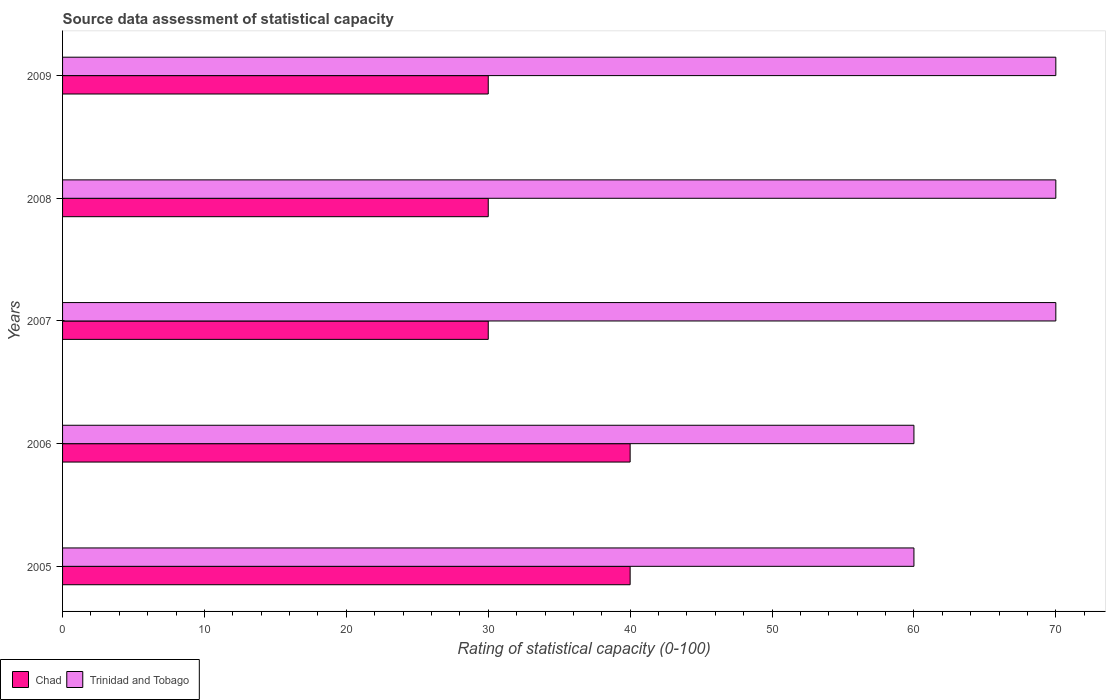How many different coloured bars are there?
Provide a succinct answer. 2. How many groups of bars are there?
Give a very brief answer. 5. Are the number of bars per tick equal to the number of legend labels?
Provide a short and direct response. Yes. Are the number of bars on each tick of the Y-axis equal?
Give a very brief answer. Yes. What is the label of the 3rd group of bars from the top?
Offer a very short reply. 2007. In how many cases, is the number of bars for a given year not equal to the number of legend labels?
Provide a short and direct response. 0. What is the rating of statistical capacity in Chad in 2009?
Your answer should be very brief. 30. Across all years, what is the maximum rating of statistical capacity in Trinidad and Tobago?
Provide a short and direct response. 70. Across all years, what is the minimum rating of statistical capacity in Trinidad and Tobago?
Provide a succinct answer. 60. In which year was the rating of statistical capacity in Chad maximum?
Offer a terse response. 2005. In which year was the rating of statistical capacity in Chad minimum?
Provide a short and direct response. 2007. What is the total rating of statistical capacity in Chad in the graph?
Your answer should be very brief. 170. What is the difference between the rating of statistical capacity in Chad in 2006 and that in 2009?
Give a very brief answer. 10. What is the difference between the rating of statistical capacity in Chad in 2006 and the rating of statistical capacity in Trinidad and Tobago in 2005?
Your answer should be compact. -20. What is the average rating of statistical capacity in Chad per year?
Offer a terse response. 34. In the year 2009, what is the difference between the rating of statistical capacity in Trinidad and Tobago and rating of statistical capacity in Chad?
Offer a very short reply. 40. What is the ratio of the rating of statistical capacity in Trinidad and Tobago in 2008 to that in 2009?
Give a very brief answer. 1. What is the difference between the highest and the lowest rating of statistical capacity in Trinidad and Tobago?
Make the answer very short. 10. In how many years, is the rating of statistical capacity in Trinidad and Tobago greater than the average rating of statistical capacity in Trinidad and Tobago taken over all years?
Make the answer very short. 3. What does the 2nd bar from the top in 2006 represents?
Offer a terse response. Chad. What does the 2nd bar from the bottom in 2005 represents?
Offer a very short reply. Trinidad and Tobago. How many bars are there?
Keep it short and to the point. 10. How many years are there in the graph?
Your response must be concise. 5. What is the difference between two consecutive major ticks on the X-axis?
Offer a very short reply. 10. Does the graph contain any zero values?
Make the answer very short. No. Where does the legend appear in the graph?
Give a very brief answer. Bottom left. How are the legend labels stacked?
Provide a short and direct response. Horizontal. What is the title of the graph?
Provide a succinct answer. Source data assessment of statistical capacity. Does "Greenland" appear as one of the legend labels in the graph?
Your answer should be compact. No. What is the label or title of the X-axis?
Your answer should be very brief. Rating of statistical capacity (0-100). What is the label or title of the Y-axis?
Your answer should be very brief. Years. What is the Rating of statistical capacity (0-100) in Trinidad and Tobago in 2005?
Ensure brevity in your answer.  60. What is the Rating of statistical capacity (0-100) in Trinidad and Tobago in 2006?
Give a very brief answer. 60. What is the Rating of statistical capacity (0-100) in Chad in 2007?
Give a very brief answer. 30. What is the Rating of statistical capacity (0-100) in Trinidad and Tobago in 2009?
Provide a short and direct response. 70. Across all years, what is the maximum Rating of statistical capacity (0-100) in Chad?
Offer a terse response. 40. Across all years, what is the maximum Rating of statistical capacity (0-100) of Trinidad and Tobago?
Offer a very short reply. 70. Across all years, what is the minimum Rating of statistical capacity (0-100) in Chad?
Offer a very short reply. 30. What is the total Rating of statistical capacity (0-100) of Chad in the graph?
Provide a short and direct response. 170. What is the total Rating of statistical capacity (0-100) in Trinidad and Tobago in the graph?
Your response must be concise. 330. What is the difference between the Rating of statistical capacity (0-100) in Trinidad and Tobago in 2005 and that in 2006?
Your answer should be very brief. 0. What is the difference between the Rating of statistical capacity (0-100) of Chad in 2005 and that in 2008?
Give a very brief answer. 10. What is the difference between the Rating of statistical capacity (0-100) of Trinidad and Tobago in 2005 and that in 2008?
Your answer should be compact. -10. What is the difference between the Rating of statistical capacity (0-100) of Chad in 2006 and that in 2007?
Give a very brief answer. 10. What is the difference between the Rating of statistical capacity (0-100) in Trinidad and Tobago in 2006 and that in 2007?
Give a very brief answer. -10. What is the difference between the Rating of statistical capacity (0-100) of Chad in 2006 and that in 2009?
Your answer should be compact. 10. What is the difference between the Rating of statistical capacity (0-100) in Trinidad and Tobago in 2006 and that in 2009?
Your answer should be very brief. -10. What is the difference between the Rating of statistical capacity (0-100) in Chad in 2007 and that in 2008?
Offer a very short reply. 0. What is the difference between the Rating of statistical capacity (0-100) of Trinidad and Tobago in 2007 and that in 2008?
Provide a short and direct response. 0. What is the difference between the Rating of statistical capacity (0-100) in Chad in 2008 and that in 2009?
Offer a terse response. 0. What is the difference between the Rating of statistical capacity (0-100) of Chad in 2005 and the Rating of statistical capacity (0-100) of Trinidad and Tobago in 2007?
Your response must be concise. -30. What is the difference between the Rating of statistical capacity (0-100) in Chad in 2006 and the Rating of statistical capacity (0-100) in Trinidad and Tobago in 2007?
Make the answer very short. -30. What is the difference between the Rating of statistical capacity (0-100) of Chad in 2006 and the Rating of statistical capacity (0-100) of Trinidad and Tobago in 2008?
Your answer should be very brief. -30. What is the difference between the Rating of statistical capacity (0-100) of Chad in 2006 and the Rating of statistical capacity (0-100) of Trinidad and Tobago in 2009?
Keep it short and to the point. -30. What is the average Rating of statistical capacity (0-100) of Chad per year?
Ensure brevity in your answer.  34. What is the average Rating of statistical capacity (0-100) of Trinidad and Tobago per year?
Make the answer very short. 66. In the year 2005, what is the difference between the Rating of statistical capacity (0-100) of Chad and Rating of statistical capacity (0-100) of Trinidad and Tobago?
Your response must be concise. -20. In the year 2009, what is the difference between the Rating of statistical capacity (0-100) in Chad and Rating of statistical capacity (0-100) in Trinidad and Tobago?
Your answer should be compact. -40. What is the ratio of the Rating of statistical capacity (0-100) in Chad in 2005 to that in 2006?
Ensure brevity in your answer.  1. What is the ratio of the Rating of statistical capacity (0-100) of Trinidad and Tobago in 2005 to that in 2006?
Provide a short and direct response. 1. What is the ratio of the Rating of statistical capacity (0-100) in Chad in 2005 to that in 2007?
Provide a succinct answer. 1.33. What is the ratio of the Rating of statistical capacity (0-100) in Chad in 2005 to that in 2008?
Your answer should be very brief. 1.33. What is the ratio of the Rating of statistical capacity (0-100) in Chad in 2005 to that in 2009?
Give a very brief answer. 1.33. What is the ratio of the Rating of statistical capacity (0-100) in Trinidad and Tobago in 2006 to that in 2007?
Provide a succinct answer. 0.86. What is the ratio of the Rating of statistical capacity (0-100) of Trinidad and Tobago in 2007 to that in 2008?
Ensure brevity in your answer.  1. What is the ratio of the Rating of statistical capacity (0-100) in Chad in 2007 to that in 2009?
Provide a short and direct response. 1. What is the ratio of the Rating of statistical capacity (0-100) in Trinidad and Tobago in 2007 to that in 2009?
Offer a very short reply. 1. What is the difference between the highest and the second highest Rating of statistical capacity (0-100) of Trinidad and Tobago?
Ensure brevity in your answer.  0. 